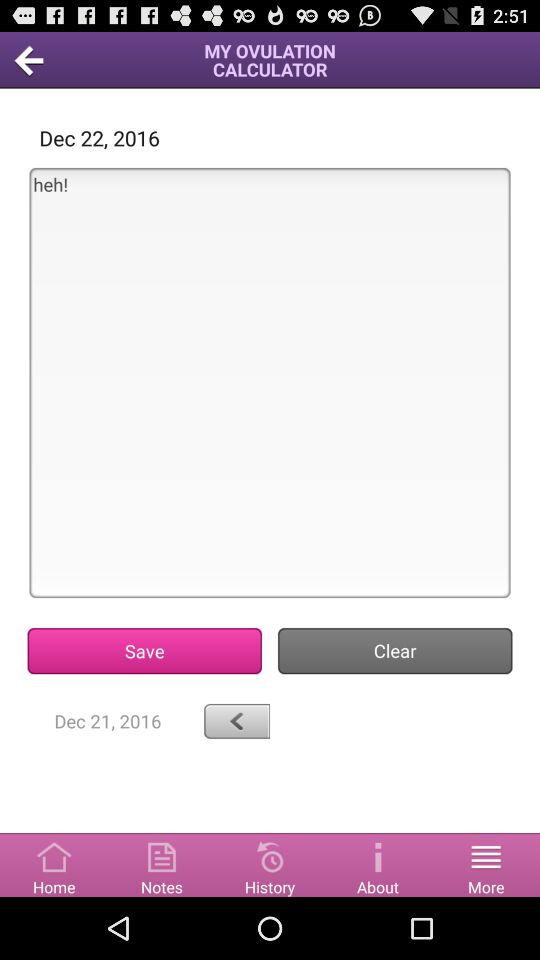Which tab has been selected? The tab "More" has been selected. 